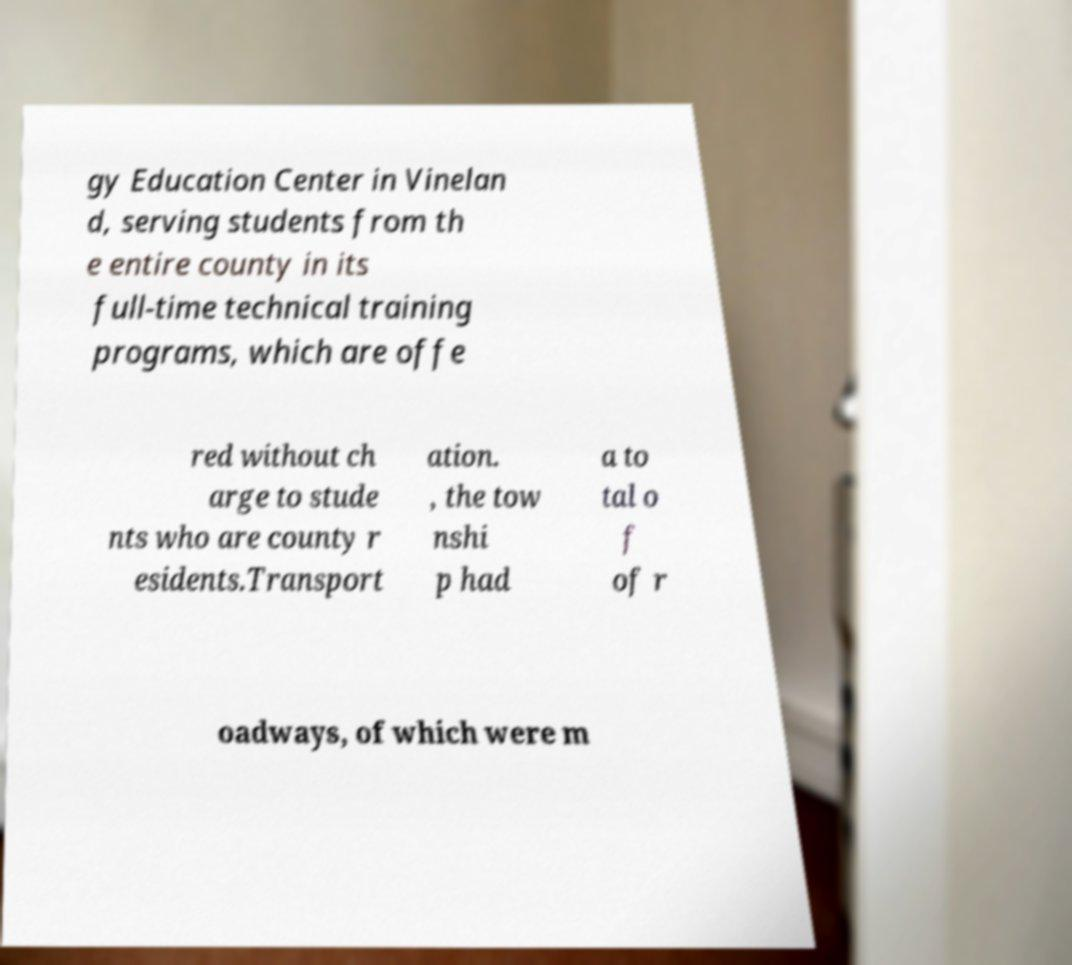Could you assist in decoding the text presented in this image and type it out clearly? gy Education Center in Vinelan d, serving students from th e entire county in its full-time technical training programs, which are offe red without ch arge to stude nts who are county r esidents.Transport ation. , the tow nshi p had a to tal o f of r oadways, of which were m 